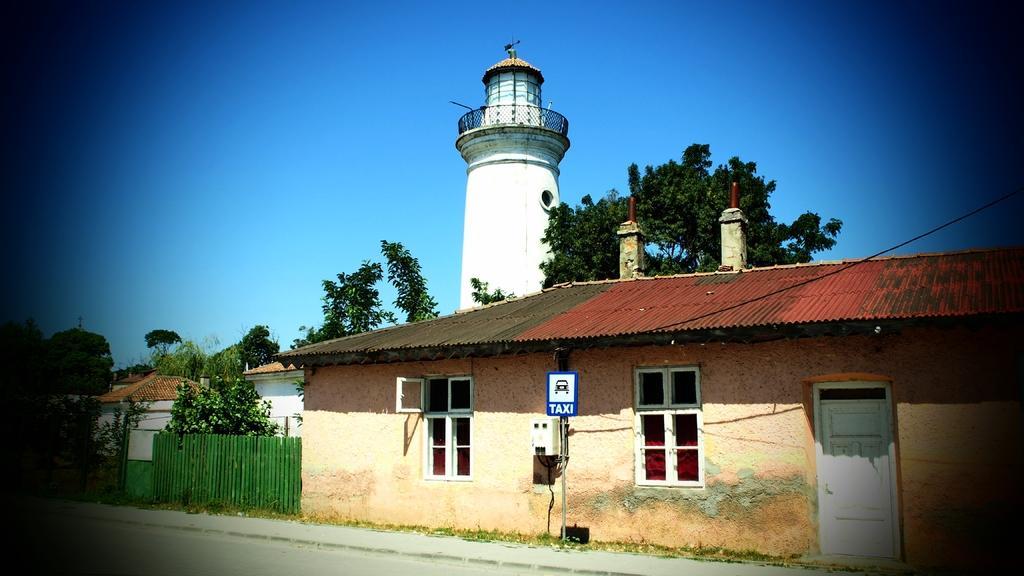Describe this image in one or two sentences. In this picture we can see houses, trees, a tower and fence. At the top of the image, there is the sky. At the bottom of the image, there is a road. 